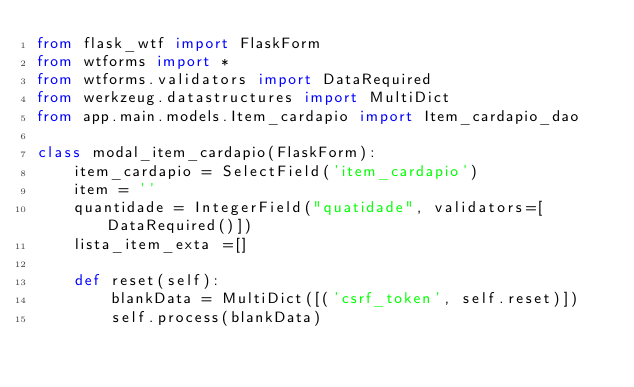Convert code to text. <code><loc_0><loc_0><loc_500><loc_500><_Python_>from flask_wtf import FlaskForm
from wtforms import *
from wtforms.validators import DataRequired
from werkzeug.datastructures import MultiDict
from app.main.models.Item_cardapio import Item_cardapio_dao

class modal_item_cardapio(FlaskForm):
    item_cardapio = SelectField('item_cardapio')
    item = ''
    quantidade = IntegerField("quatidade", validators=[DataRequired()])
    lista_item_exta =[]

    def reset(self):
        blankData = MultiDict([('csrf_token', self.reset)])
        self.process(blankData)




</code> 